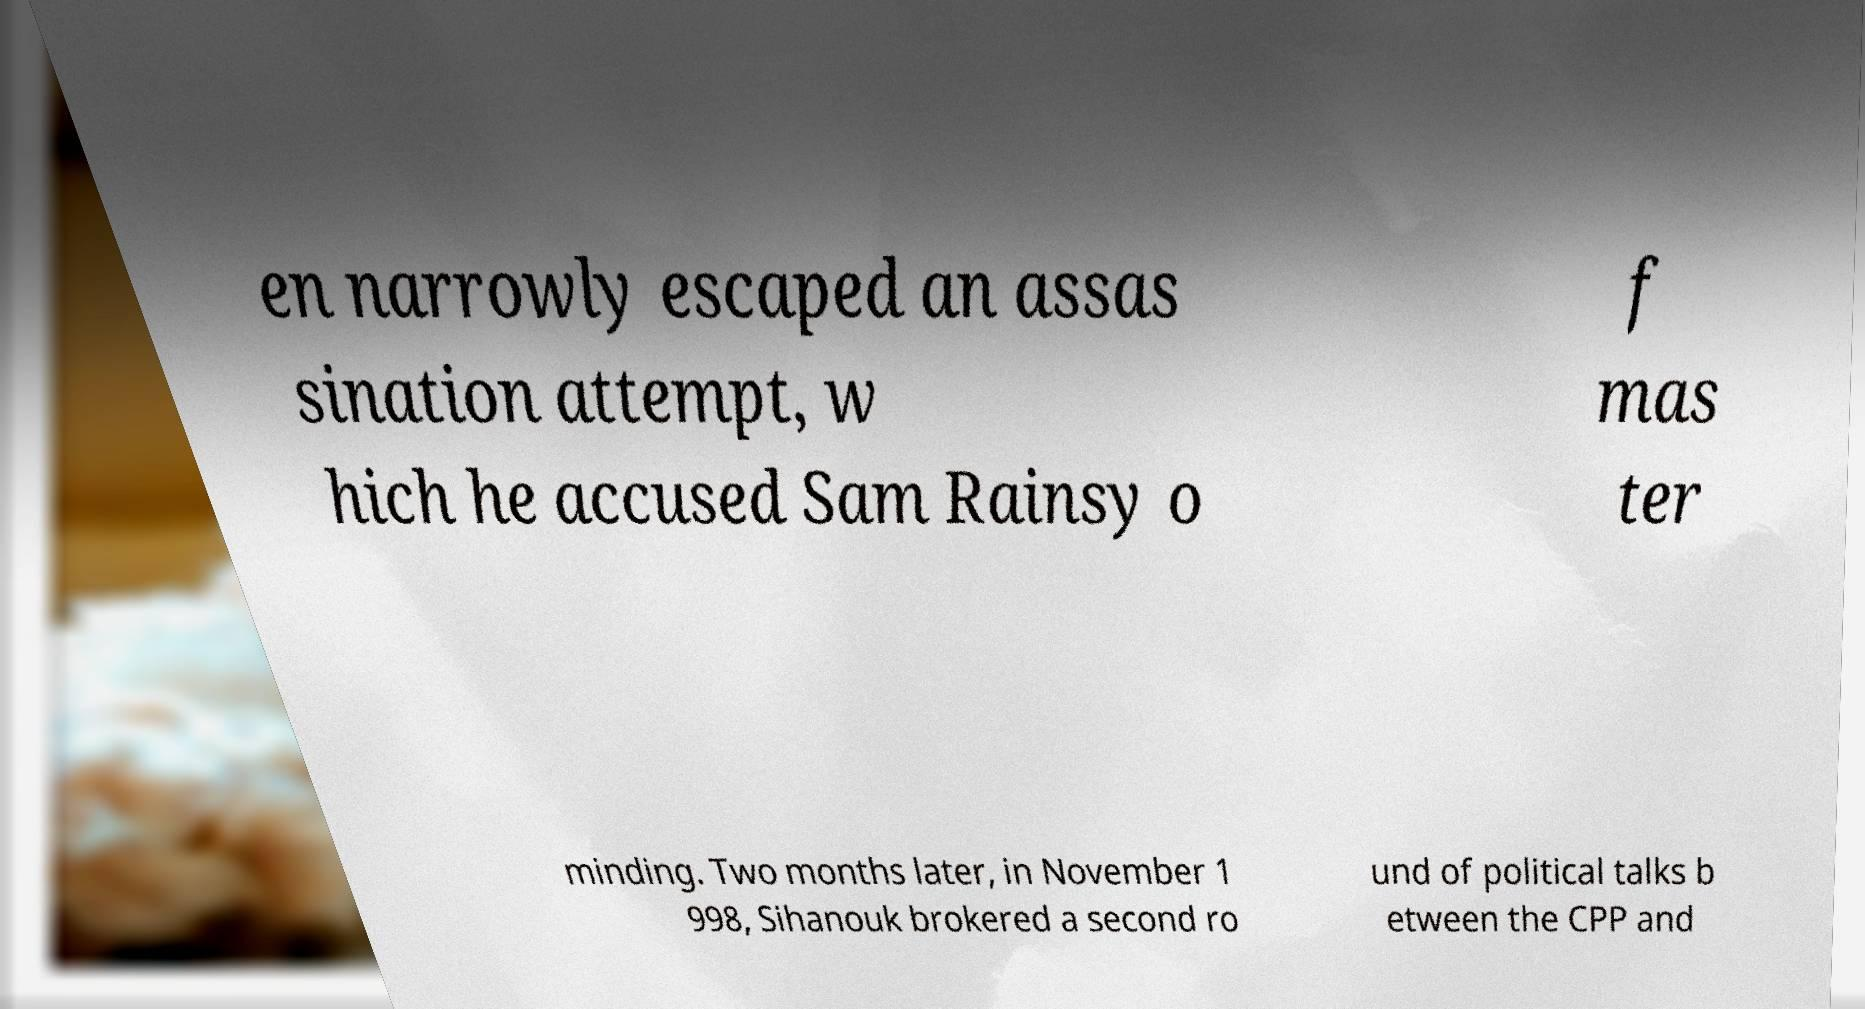For documentation purposes, I need the text within this image transcribed. Could you provide that? en narrowly escaped an assas sination attempt, w hich he accused Sam Rainsy o f mas ter minding. Two months later, in November 1 998, Sihanouk brokered a second ro und of political talks b etween the CPP and 